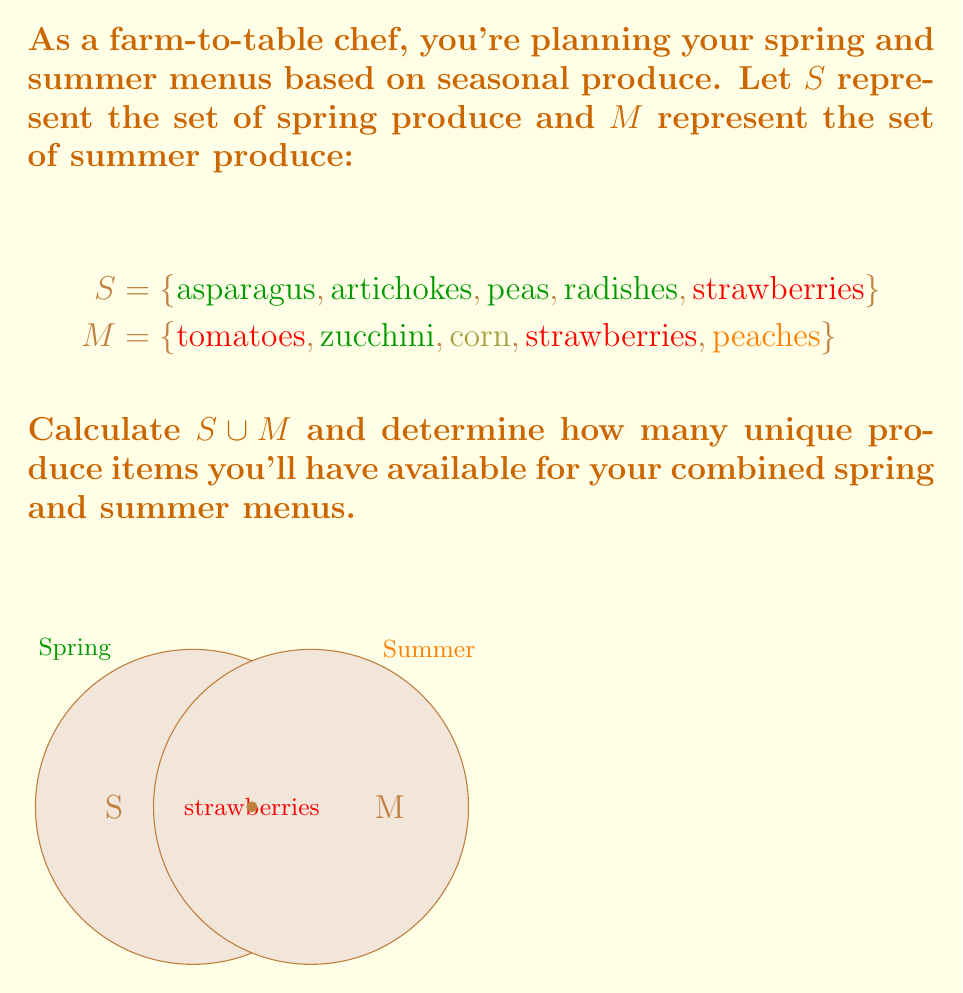Can you solve this math problem? To solve this problem, we need to find the union of sets $S$ and $M$, denoted as $S \cup M$. The union of two sets contains all elements that are in either set, without duplicates.

Step 1: List all unique elements from both sets.
$S \cup M = \{\text{asparagus}, \text{artichokes}, \text{peas}, \text{radishes}, \text{strawberries}, \text{tomatoes}, \text{zucchini}, \text{corn}, \text{peaches}\}$

Step 2: Count the number of elements in the union.
Note that "strawberries" appears in both sets but is only counted once in the union.

Number of elements in $S \cup M = 9$

Therefore, you'll have 9 unique produce items available for your combined spring and summer menus.
Answer: $|S \cup M| = 9$ 